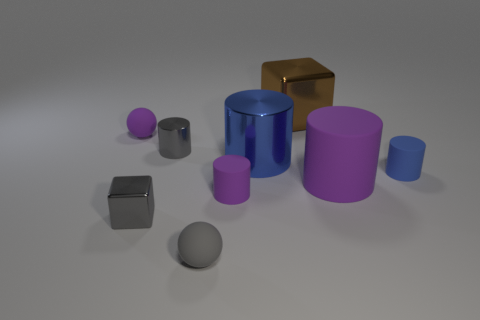What number of other objects are there of the same color as the tiny block?
Your answer should be very brief. 2. There is a small purple rubber cylinder; are there any large brown things behind it?
Your answer should be very brief. Yes. How many brown blocks are made of the same material as the gray block?
Your answer should be compact. 1. How many objects are either big brown shiny cubes or tiny shiny cylinders?
Offer a terse response. 2. Is there a big gray block?
Give a very brief answer. No. The purple thing that is in front of the purple thing that is right of the purple cylinder that is left of the blue metallic cylinder is made of what material?
Ensure brevity in your answer.  Rubber. Are there fewer large blue cylinders in front of the gray rubber sphere than tiny red metal objects?
Ensure brevity in your answer.  No. What is the material of the gray cylinder that is the same size as the gray metallic block?
Make the answer very short. Metal. There is a object that is both right of the large blue thing and behind the small blue rubber cylinder; what is its size?
Your answer should be very brief. Large. The gray shiny thing that is the same shape as the blue rubber object is what size?
Your answer should be compact. Small. 